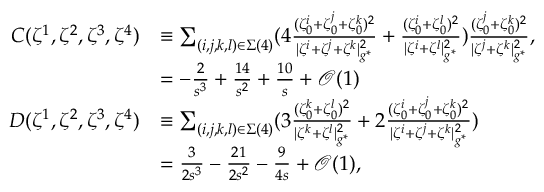<formula> <loc_0><loc_0><loc_500><loc_500>\begin{array} { r l } { C ( \zeta ^ { 1 } , \zeta ^ { 2 } , \zeta ^ { 3 } , \zeta ^ { 4 } ) } & { \equiv \sum _ { ( i , j , k , l ) \in \Sigma ( 4 ) } ( 4 \frac { ( \zeta _ { 0 } ^ { i } + \zeta _ { 0 } ^ { j } + \zeta _ { 0 } ^ { k } ) ^ { 2 } } { | { \zeta ^ { i } } + { \zeta ^ { j } } + { \zeta ^ { k } } | _ { g ^ { * } } ^ { 2 } } + \frac { ( \zeta _ { 0 } ^ { i } + \zeta _ { 0 } ^ { l } ) ^ { 2 } } { | { \zeta ^ { i } } + { \zeta ^ { l } } | _ { g ^ { * } } ^ { 2 } } ) \frac { ( \zeta _ { 0 } ^ { j } + \zeta _ { 0 } ^ { k } ) ^ { 2 } } { | { \zeta ^ { j } } + { \zeta ^ { k } } | _ { g ^ { * } } ^ { 2 } } , } \\ & { = - \frac { 2 } { s ^ { 3 } } + \frac { 1 4 } { s ^ { 2 } } + \frac { 1 0 } { s } + \mathcal { O } ( 1 ) } \\ { D ( \zeta ^ { 1 } , \zeta ^ { 2 } , \zeta ^ { 3 } , \zeta ^ { 4 } ) } & { \equiv \sum _ { ( i , j , k , l ) \in \Sigma ( 4 ) } ( 3 \frac { ( \zeta _ { 0 } ^ { k } + \zeta _ { 0 } ^ { l } ) ^ { 2 } } { | { \zeta ^ { k } } + { \zeta ^ { l } } | _ { g ^ { * } } ^ { 2 } } + 2 \frac { ( \zeta _ { 0 } ^ { i } + \zeta _ { 0 } ^ { j } + \zeta _ { 0 } ^ { k } ) ^ { 2 } } { | { \zeta ^ { i } } + { \zeta ^ { j } } + { \zeta ^ { k } } | _ { g ^ { * } } ^ { 2 } } ) } \\ & { = \frac { 3 } { 2 s ^ { 3 } } - \frac { 2 1 } { 2 s ^ { 2 } } - \frac { 9 } { 4 s } + \mathcal { O } ( 1 ) , } \end{array}</formula> 